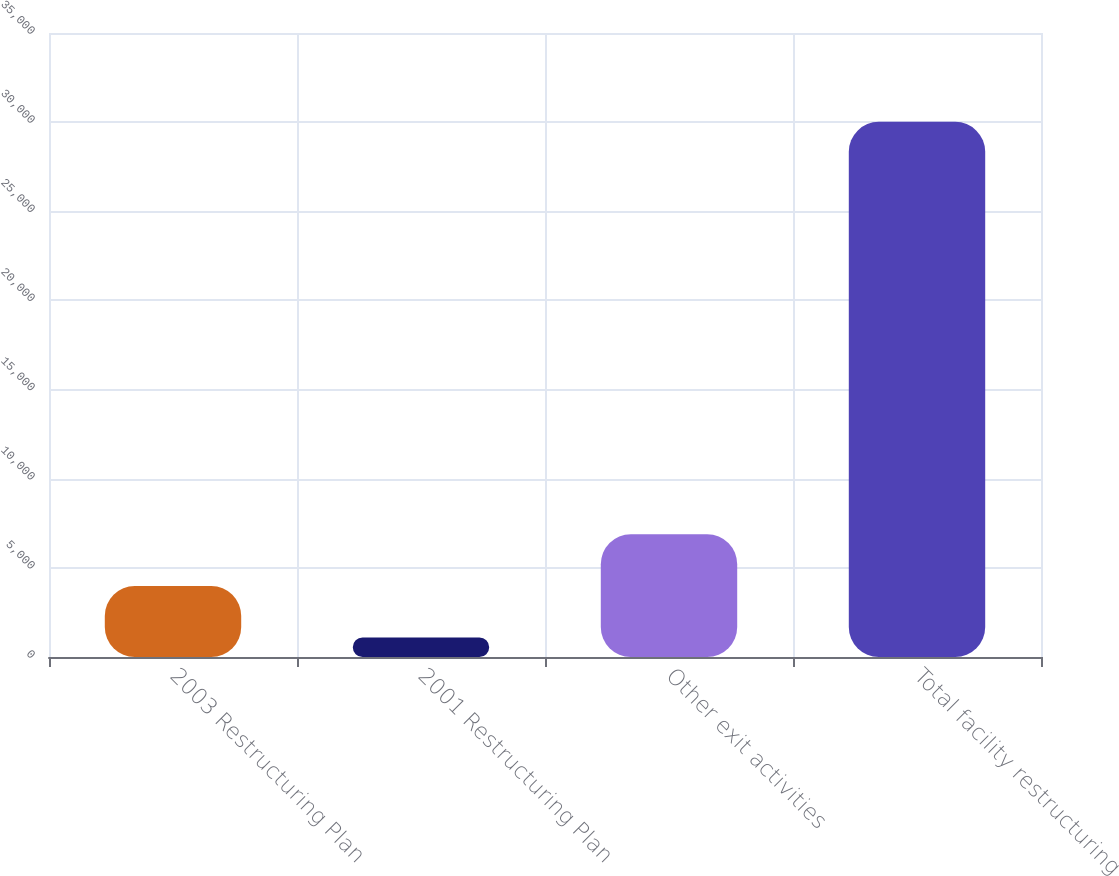Convert chart. <chart><loc_0><loc_0><loc_500><loc_500><bar_chart><fcel>2003 Restructuring Plan<fcel>2001 Restructuring Plan<fcel>Other exit activities<fcel>Total facility restructuring<nl><fcel>3988.1<fcel>1096<fcel>6880.2<fcel>30017<nl></chart> 